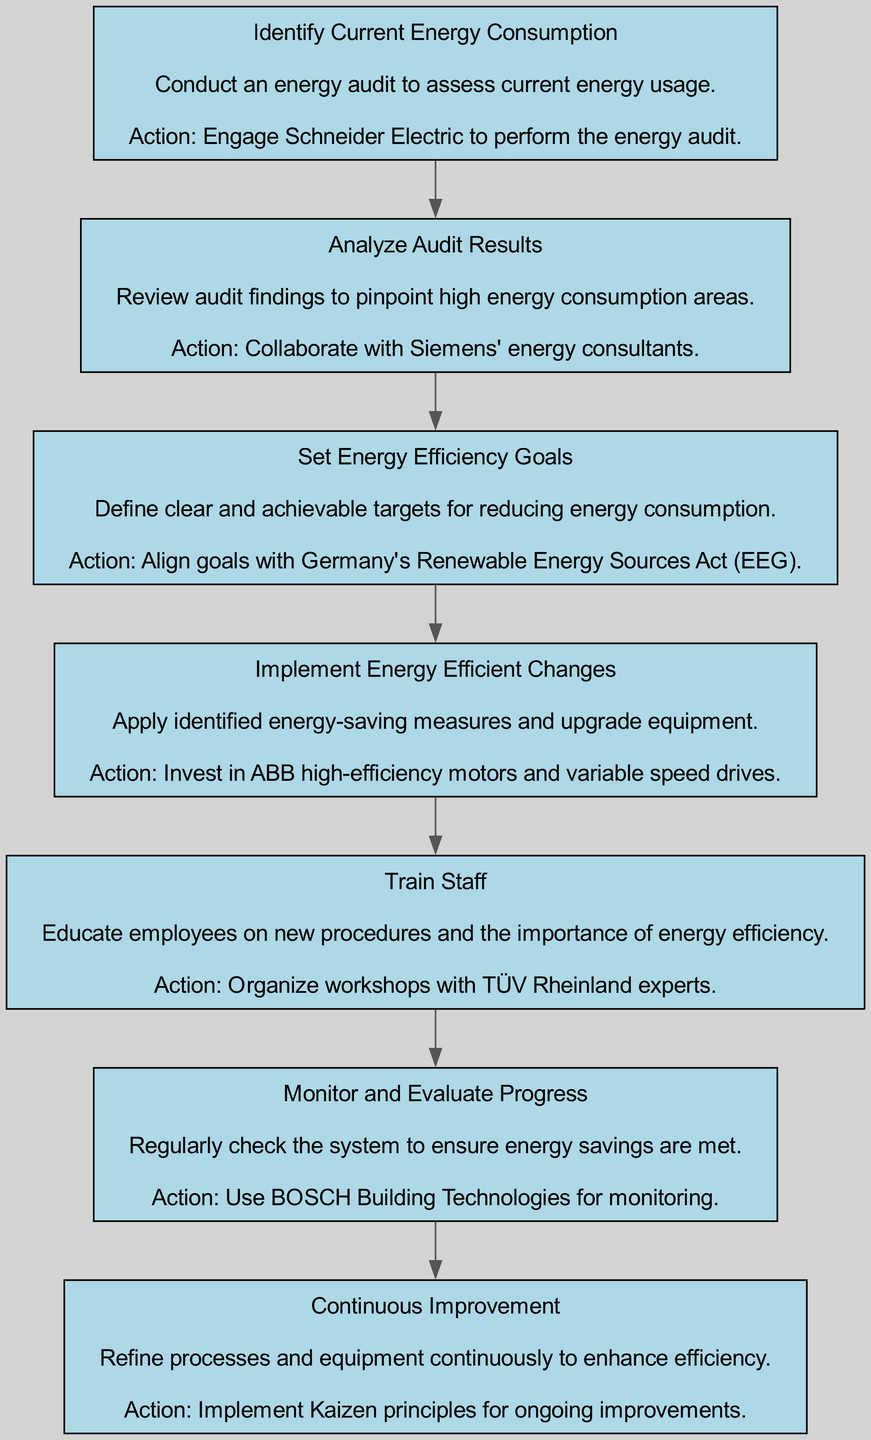What is the first step in the process? The first step in the flow chart is "Identify Current Energy Consumption," which is indicated as the initial node. This node is positioned at the top of the flow chart, marking the starting point for the series of actions to be taken.
Answer: Identify Current Energy Consumption How many total steps are there in the process? By counting each node in the flow chart, we find there are seven distinct steps from "Identify Current Energy Consumption" to "Continuous Improvement." This includes all the nodes connected in the sequential flow.
Answer: Seven What does the "Monitor and Evaluate Progress" step lead to? The "Monitor and Evaluate Progress" step is directly followed by the "Continuous Improvement" node in the flow chart, indicating a flow from monitoring to ongoing enhancements.
Answer: Continuous Improvement Which step involves staff training? The step focused on staff education and training is labeled "Train Staff," which emphasizes the need to inform employees about new procedures and the importance of energy efficiency.
Answer: Train Staff What action is suggested for implementing energy-efficient changes? The action prescribed under "Implement Energy Efficient Changes" is to invest in ABB high-efficiency motors and variable speed drives, aimed at applying energy-saving measures.
Answer: Invest in ABB high-efficiency motors and variable speed drives Which company is involved in conducting the energy audit? The company responsible for conducting the energy audit, as indicated in the "Identify Current Energy Consumption" node, is Schneider Electric. This step emphasizes the engagement of external expertise for the audit.
Answer: Schneider Electric What principle is suggested for ongoing improvements? The flow chart refers to the implementation of "Kaizen principles" under the "Continuous Improvement" node, highlighting a strategy for ongoing enhancement of processes and equipment.
Answer: Kaizen principles 